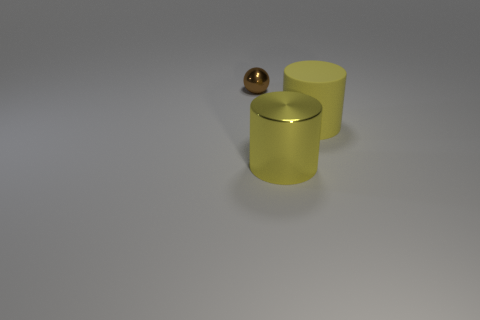Does the cylinder behind the metal cylinder have the same size as the metallic object that is on the right side of the tiny brown ball?
Provide a succinct answer. Yes. Is there anything else that has the same material as the brown sphere?
Offer a very short reply. Yes. There is a large cylinder in front of the thing right of the metal thing right of the shiny ball; what is it made of?
Keep it short and to the point. Metal. Is the shape of the yellow metal object the same as the small metallic object?
Offer a terse response. No. What is the material of the other object that is the same shape as the yellow metallic object?
Offer a very short reply. Rubber. How many big metal objects are the same color as the matte thing?
Ensure brevity in your answer.  1. What size is the yellow thing that is made of the same material as the small brown thing?
Give a very brief answer. Large. How many yellow objects are either rubber things or cylinders?
Give a very brief answer. 2. What number of yellow objects are in front of the shiny object that is in front of the brown metal thing?
Give a very brief answer. 0. Are there more yellow rubber cylinders in front of the big metal cylinder than matte cylinders that are right of the small ball?
Keep it short and to the point. No. 